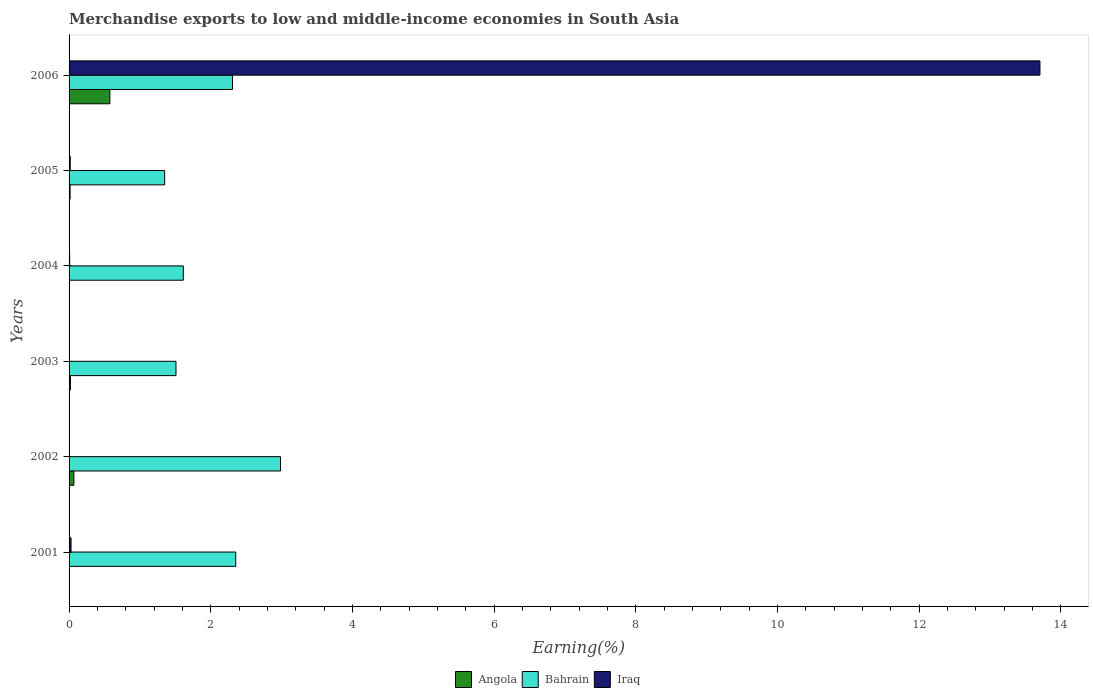How many different coloured bars are there?
Ensure brevity in your answer.  3. How many groups of bars are there?
Ensure brevity in your answer.  6. Are the number of bars per tick equal to the number of legend labels?
Offer a terse response. Yes. How many bars are there on the 4th tick from the bottom?
Ensure brevity in your answer.  3. What is the percentage of amount earned from merchandise exports in Bahrain in 2003?
Give a very brief answer. 1.51. Across all years, what is the maximum percentage of amount earned from merchandise exports in Angola?
Keep it short and to the point. 0.58. Across all years, what is the minimum percentage of amount earned from merchandise exports in Iraq?
Offer a terse response. 0. In which year was the percentage of amount earned from merchandise exports in Bahrain minimum?
Your answer should be very brief. 2005. What is the total percentage of amount earned from merchandise exports in Iraq in the graph?
Provide a short and direct response. 13.76. What is the difference between the percentage of amount earned from merchandise exports in Bahrain in 2005 and that in 2006?
Provide a succinct answer. -0.96. What is the difference between the percentage of amount earned from merchandise exports in Iraq in 2006 and the percentage of amount earned from merchandise exports in Angola in 2001?
Your response must be concise. 13.71. What is the average percentage of amount earned from merchandise exports in Bahrain per year?
Offer a terse response. 2.02. In the year 2001, what is the difference between the percentage of amount earned from merchandise exports in Iraq and percentage of amount earned from merchandise exports in Bahrain?
Keep it short and to the point. -2.33. What is the ratio of the percentage of amount earned from merchandise exports in Angola in 2004 to that in 2006?
Offer a very short reply. 0.01. Is the percentage of amount earned from merchandise exports in Iraq in 2001 less than that in 2003?
Your response must be concise. No. Is the difference between the percentage of amount earned from merchandise exports in Iraq in 2002 and 2004 greater than the difference between the percentage of amount earned from merchandise exports in Bahrain in 2002 and 2004?
Your answer should be compact. No. What is the difference between the highest and the second highest percentage of amount earned from merchandise exports in Bahrain?
Give a very brief answer. 0.63. What is the difference between the highest and the lowest percentage of amount earned from merchandise exports in Iraq?
Provide a succinct answer. 13.71. In how many years, is the percentage of amount earned from merchandise exports in Bahrain greater than the average percentage of amount earned from merchandise exports in Bahrain taken over all years?
Keep it short and to the point. 3. What does the 1st bar from the top in 2005 represents?
Ensure brevity in your answer.  Iraq. What does the 3rd bar from the bottom in 2003 represents?
Your answer should be compact. Iraq. Is it the case that in every year, the sum of the percentage of amount earned from merchandise exports in Angola and percentage of amount earned from merchandise exports in Iraq is greater than the percentage of amount earned from merchandise exports in Bahrain?
Your answer should be very brief. No. What is the difference between two consecutive major ticks on the X-axis?
Provide a succinct answer. 2. Does the graph contain grids?
Provide a succinct answer. No. What is the title of the graph?
Provide a succinct answer. Merchandise exports to low and middle-income economies in South Asia. Does "Poland" appear as one of the legend labels in the graph?
Your answer should be very brief. No. What is the label or title of the X-axis?
Provide a succinct answer. Earning(%). What is the label or title of the Y-axis?
Give a very brief answer. Years. What is the Earning(%) of Angola in 2001?
Offer a very short reply. 0. What is the Earning(%) in Bahrain in 2001?
Your answer should be compact. 2.35. What is the Earning(%) in Iraq in 2001?
Ensure brevity in your answer.  0.03. What is the Earning(%) in Angola in 2002?
Your response must be concise. 0.07. What is the Earning(%) in Bahrain in 2002?
Provide a succinct answer. 2.99. What is the Earning(%) in Iraq in 2002?
Your answer should be compact. 0. What is the Earning(%) in Angola in 2003?
Your response must be concise. 0.02. What is the Earning(%) in Bahrain in 2003?
Offer a very short reply. 1.51. What is the Earning(%) of Iraq in 2003?
Offer a terse response. 0. What is the Earning(%) in Angola in 2004?
Your answer should be very brief. 0. What is the Earning(%) of Bahrain in 2004?
Give a very brief answer. 1.61. What is the Earning(%) of Iraq in 2004?
Provide a succinct answer. 0.01. What is the Earning(%) of Angola in 2005?
Keep it short and to the point. 0.01. What is the Earning(%) of Bahrain in 2005?
Your response must be concise. 1.35. What is the Earning(%) in Iraq in 2005?
Your answer should be compact. 0.02. What is the Earning(%) in Angola in 2006?
Make the answer very short. 0.58. What is the Earning(%) in Bahrain in 2006?
Keep it short and to the point. 2.31. What is the Earning(%) in Iraq in 2006?
Provide a succinct answer. 13.71. Across all years, what is the maximum Earning(%) of Angola?
Your answer should be compact. 0.58. Across all years, what is the maximum Earning(%) in Bahrain?
Your answer should be compact. 2.99. Across all years, what is the maximum Earning(%) of Iraq?
Your answer should be very brief. 13.71. Across all years, what is the minimum Earning(%) in Angola?
Make the answer very short. 0. Across all years, what is the minimum Earning(%) in Bahrain?
Make the answer very short. 1.35. Across all years, what is the minimum Earning(%) in Iraq?
Make the answer very short. 0. What is the total Earning(%) in Angola in the graph?
Give a very brief answer. 0.68. What is the total Earning(%) of Bahrain in the graph?
Give a very brief answer. 12.12. What is the total Earning(%) of Iraq in the graph?
Your answer should be compact. 13.76. What is the difference between the Earning(%) in Angola in 2001 and that in 2002?
Give a very brief answer. -0.07. What is the difference between the Earning(%) of Bahrain in 2001 and that in 2002?
Give a very brief answer. -0.63. What is the difference between the Earning(%) in Iraq in 2001 and that in 2002?
Give a very brief answer. 0.03. What is the difference between the Earning(%) of Angola in 2001 and that in 2003?
Make the answer very short. -0.02. What is the difference between the Earning(%) in Bahrain in 2001 and that in 2003?
Make the answer very short. 0.84. What is the difference between the Earning(%) of Iraq in 2001 and that in 2003?
Keep it short and to the point. 0.03. What is the difference between the Earning(%) of Angola in 2001 and that in 2004?
Provide a short and direct response. -0. What is the difference between the Earning(%) in Bahrain in 2001 and that in 2004?
Offer a terse response. 0.74. What is the difference between the Earning(%) of Iraq in 2001 and that in 2004?
Ensure brevity in your answer.  0.02. What is the difference between the Earning(%) in Angola in 2001 and that in 2005?
Your response must be concise. -0.01. What is the difference between the Earning(%) of Bahrain in 2001 and that in 2005?
Offer a terse response. 1. What is the difference between the Earning(%) of Iraq in 2001 and that in 2005?
Ensure brevity in your answer.  0.01. What is the difference between the Earning(%) of Angola in 2001 and that in 2006?
Make the answer very short. -0.58. What is the difference between the Earning(%) of Bahrain in 2001 and that in 2006?
Offer a terse response. 0.05. What is the difference between the Earning(%) of Iraq in 2001 and that in 2006?
Offer a very short reply. -13.68. What is the difference between the Earning(%) of Angola in 2002 and that in 2003?
Ensure brevity in your answer.  0.05. What is the difference between the Earning(%) of Bahrain in 2002 and that in 2003?
Give a very brief answer. 1.48. What is the difference between the Earning(%) in Angola in 2002 and that in 2004?
Your answer should be very brief. 0.06. What is the difference between the Earning(%) in Bahrain in 2002 and that in 2004?
Keep it short and to the point. 1.37. What is the difference between the Earning(%) of Iraq in 2002 and that in 2004?
Keep it short and to the point. -0.01. What is the difference between the Earning(%) of Angola in 2002 and that in 2005?
Your answer should be very brief. 0.05. What is the difference between the Earning(%) in Bahrain in 2002 and that in 2005?
Your response must be concise. 1.64. What is the difference between the Earning(%) of Iraq in 2002 and that in 2005?
Make the answer very short. -0.01. What is the difference between the Earning(%) of Angola in 2002 and that in 2006?
Provide a succinct answer. -0.51. What is the difference between the Earning(%) in Bahrain in 2002 and that in 2006?
Your answer should be very brief. 0.68. What is the difference between the Earning(%) of Iraq in 2002 and that in 2006?
Ensure brevity in your answer.  -13.71. What is the difference between the Earning(%) of Angola in 2003 and that in 2004?
Offer a terse response. 0.01. What is the difference between the Earning(%) of Bahrain in 2003 and that in 2004?
Your response must be concise. -0.1. What is the difference between the Earning(%) in Iraq in 2003 and that in 2004?
Offer a terse response. -0.01. What is the difference between the Earning(%) in Angola in 2003 and that in 2005?
Offer a very short reply. 0. What is the difference between the Earning(%) of Bahrain in 2003 and that in 2005?
Give a very brief answer. 0.16. What is the difference between the Earning(%) in Iraq in 2003 and that in 2005?
Provide a succinct answer. -0.01. What is the difference between the Earning(%) in Angola in 2003 and that in 2006?
Ensure brevity in your answer.  -0.56. What is the difference between the Earning(%) in Bahrain in 2003 and that in 2006?
Provide a short and direct response. -0.8. What is the difference between the Earning(%) of Iraq in 2003 and that in 2006?
Ensure brevity in your answer.  -13.71. What is the difference between the Earning(%) of Angola in 2004 and that in 2005?
Your response must be concise. -0.01. What is the difference between the Earning(%) in Bahrain in 2004 and that in 2005?
Offer a terse response. 0.26. What is the difference between the Earning(%) in Iraq in 2004 and that in 2005?
Ensure brevity in your answer.  -0.01. What is the difference between the Earning(%) in Angola in 2004 and that in 2006?
Provide a short and direct response. -0.57. What is the difference between the Earning(%) of Bahrain in 2004 and that in 2006?
Keep it short and to the point. -0.69. What is the difference between the Earning(%) in Iraq in 2004 and that in 2006?
Offer a terse response. -13.7. What is the difference between the Earning(%) of Angola in 2005 and that in 2006?
Make the answer very short. -0.56. What is the difference between the Earning(%) in Bahrain in 2005 and that in 2006?
Give a very brief answer. -0.96. What is the difference between the Earning(%) in Iraq in 2005 and that in 2006?
Provide a short and direct response. -13.69. What is the difference between the Earning(%) in Angola in 2001 and the Earning(%) in Bahrain in 2002?
Your response must be concise. -2.99. What is the difference between the Earning(%) of Angola in 2001 and the Earning(%) of Iraq in 2002?
Your response must be concise. -0. What is the difference between the Earning(%) in Bahrain in 2001 and the Earning(%) in Iraq in 2002?
Your response must be concise. 2.35. What is the difference between the Earning(%) of Angola in 2001 and the Earning(%) of Bahrain in 2003?
Give a very brief answer. -1.51. What is the difference between the Earning(%) in Angola in 2001 and the Earning(%) in Iraq in 2003?
Your response must be concise. -0. What is the difference between the Earning(%) of Bahrain in 2001 and the Earning(%) of Iraq in 2003?
Ensure brevity in your answer.  2.35. What is the difference between the Earning(%) in Angola in 2001 and the Earning(%) in Bahrain in 2004?
Your answer should be very brief. -1.61. What is the difference between the Earning(%) in Angola in 2001 and the Earning(%) in Iraq in 2004?
Your answer should be compact. -0.01. What is the difference between the Earning(%) of Bahrain in 2001 and the Earning(%) of Iraq in 2004?
Keep it short and to the point. 2.35. What is the difference between the Earning(%) of Angola in 2001 and the Earning(%) of Bahrain in 2005?
Your answer should be very brief. -1.35. What is the difference between the Earning(%) in Angola in 2001 and the Earning(%) in Iraq in 2005?
Offer a terse response. -0.02. What is the difference between the Earning(%) of Bahrain in 2001 and the Earning(%) of Iraq in 2005?
Keep it short and to the point. 2.34. What is the difference between the Earning(%) in Angola in 2001 and the Earning(%) in Bahrain in 2006?
Your response must be concise. -2.31. What is the difference between the Earning(%) in Angola in 2001 and the Earning(%) in Iraq in 2006?
Give a very brief answer. -13.71. What is the difference between the Earning(%) in Bahrain in 2001 and the Earning(%) in Iraq in 2006?
Your response must be concise. -11.35. What is the difference between the Earning(%) in Angola in 2002 and the Earning(%) in Bahrain in 2003?
Your response must be concise. -1.44. What is the difference between the Earning(%) in Angola in 2002 and the Earning(%) in Iraq in 2003?
Your answer should be very brief. 0.07. What is the difference between the Earning(%) in Bahrain in 2002 and the Earning(%) in Iraq in 2003?
Provide a succinct answer. 2.98. What is the difference between the Earning(%) of Angola in 2002 and the Earning(%) of Bahrain in 2004?
Your response must be concise. -1.55. What is the difference between the Earning(%) of Angola in 2002 and the Earning(%) of Iraq in 2004?
Offer a very short reply. 0.06. What is the difference between the Earning(%) of Bahrain in 2002 and the Earning(%) of Iraq in 2004?
Your response must be concise. 2.98. What is the difference between the Earning(%) of Angola in 2002 and the Earning(%) of Bahrain in 2005?
Ensure brevity in your answer.  -1.28. What is the difference between the Earning(%) of Angola in 2002 and the Earning(%) of Iraq in 2005?
Make the answer very short. 0.05. What is the difference between the Earning(%) in Bahrain in 2002 and the Earning(%) in Iraq in 2005?
Offer a terse response. 2.97. What is the difference between the Earning(%) of Angola in 2002 and the Earning(%) of Bahrain in 2006?
Provide a succinct answer. -2.24. What is the difference between the Earning(%) of Angola in 2002 and the Earning(%) of Iraq in 2006?
Ensure brevity in your answer.  -13.64. What is the difference between the Earning(%) in Bahrain in 2002 and the Earning(%) in Iraq in 2006?
Your answer should be compact. -10.72. What is the difference between the Earning(%) in Angola in 2003 and the Earning(%) in Bahrain in 2004?
Provide a succinct answer. -1.59. What is the difference between the Earning(%) of Angola in 2003 and the Earning(%) of Iraq in 2004?
Ensure brevity in your answer.  0.01. What is the difference between the Earning(%) in Bahrain in 2003 and the Earning(%) in Iraq in 2004?
Keep it short and to the point. 1.5. What is the difference between the Earning(%) of Angola in 2003 and the Earning(%) of Bahrain in 2005?
Your answer should be very brief. -1.33. What is the difference between the Earning(%) of Angola in 2003 and the Earning(%) of Iraq in 2005?
Your response must be concise. 0. What is the difference between the Earning(%) of Bahrain in 2003 and the Earning(%) of Iraq in 2005?
Your answer should be compact. 1.49. What is the difference between the Earning(%) in Angola in 2003 and the Earning(%) in Bahrain in 2006?
Provide a succinct answer. -2.29. What is the difference between the Earning(%) of Angola in 2003 and the Earning(%) of Iraq in 2006?
Keep it short and to the point. -13.69. What is the difference between the Earning(%) in Bahrain in 2003 and the Earning(%) in Iraq in 2006?
Give a very brief answer. -12.2. What is the difference between the Earning(%) of Angola in 2004 and the Earning(%) of Bahrain in 2005?
Give a very brief answer. -1.35. What is the difference between the Earning(%) of Angola in 2004 and the Earning(%) of Iraq in 2005?
Provide a short and direct response. -0.01. What is the difference between the Earning(%) of Bahrain in 2004 and the Earning(%) of Iraq in 2005?
Offer a terse response. 1.6. What is the difference between the Earning(%) in Angola in 2004 and the Earning(%) in Bahrain in 2006?
Provide a short and direct response. -2.3. What is the difference between the Earning(%) of Angola in 2004 and the Earning(%) of Iraq in 2006?
Give a very brief answer. -13.7. What is the difference between the Earning(%) in Bahrain in 2004 and the Earning(%) in Iraq in 2006?
Provide a succinct answer. -12.09. What is the difference between the Earning(%) in Angola in 2005 and the Earning(%) in Bahrain in 2006?
Offer a very short reply. -2.29. What is the difference between the Earning(%) in Angola in 2005 and the Earning(%) in Iraq in 2006?
Provide a short and direct response. -13.69. What is the difference between the Earning(%) of Bahrain in 2005 and the Earning(%) of Iraq in 2006?
Offer a terse response. -12.36. What is the average Earning(%) in Angola per year?
Keep it short and to the point. 0.11. What is the average Earning(%) in Bahrain per year?
Provide a succinct answer. 2.02. What is the average Earning(%) of Iraq per year?
Your answer should be compact. 2.29. In the year 2001, what is the difference between the Earning(%) in Angola and Earning(%) in Bahrain?
Your answer should be compact. -2.35. In the year 2001, what is the difference between the Earning(%) in Angola and Earning(%) in Iraq?
Keep it short and to the point. -0.03. In the year 2001, what is the difference between the Earning(%) of Bahrain and Earning(%) of Iraq?
Your answer should be compact. 2.33. In the year 2002, what is the difference between the Earning(%) in Angola and Earning(%) in Bahrain?
Make the answer very short. -2.92. In the year 2002, what is the difference between the Earning(%) of Angola and Earning(%) of Iraq?
Provide a short and direct response. 0.07. In the year 2002, what is the difference between the Earning(%) in Bahrain and Earning(%) in Iraq?
Your answer should be very brief. 2.98. In the year 2003, what is the difference between the Earning(%) of Angola and Earning(%) of Bahrain?
Your answer should be very brief. -1.49. In the year 2003, what is the difference between the Earning(%) of Angola and Earning(%) of Iraq?
Make the answer very short. 0.02. In the year 2003, what is the difference between the Earning(%) in Bahrain and Earning(%) in Iraq?
Provide a succinct answer. 1.51. In the year 2004, what is the difference between the Earning(%) in Angola and Earning(%) in Bahrain?
Offer a terse response. -1.61. In the year 2004, what is the difference between the Earning(%) of Angola and Earning(%) of Iraq?
Provide a short and direct response. -0. In the year 2004, what is the difference between the Earning(%) in Bahrain and Earning(%) in Iraq?
Ensure brevity in your answer.  1.6. In the year 2005, what is the difference between the Earning(%) in Angola and Earning(%) in Bahrain?
Your answer should be compact. -1.34. In the year 2005, what is the difference between the Earning(%) in Angola and Earning(%) in Iraq?
Your answer should be very brief. -0. In the year 2005, what is the difference between the Earning(%) in Bahrain and Earning(%) in Iraq?
Provide a short and direct response. 1.33. In the year 2006, what is the difference between the Earning(%) in Angola and Earning(%) in Bahrain?
Give a very brief answer. -1.73. In the year 2006, what is the difference between the Earning(%) in Angola and Earning(%) in Iraq?
Keep it short and to the point. -13.13. In the year 2006, what is the difference between the Earning(%) of Bahrain and Earning(%) of Iraq?
Make the answer very short. -11.4. What is the ratio of the Earning(%) in Angola in 2001 to that in 2002?
Your answer should be very brief. 0. What is the ratio of the Earning(%) in Bahrain in 2001 to that in 2002?
Your response must be concise. 0.79. What is the ratio of the Earning(%) of Iraq in 2001 to that in 2002?
Offer a terse response. 14.14. What is the ratio of the Earning(%) of Angola in 2001 to that in 2003?
Offer a very short reply. 0.01. What is the ratio of the Earning(%) of Bahrain in 2001 to that in 2003?
Give a very brief answer. 1.56. What is the ratio of the Earning(%) of Iraq in 2001 to that in 2003?
Your answer should be very brief. 17.33. What is the ratio of the Earning(%) of Angola in 2001 to that in 2004?
Your answer should be compact. 0.04. What is the ratio of the Earning(%) in Bahrain in 2001 to that in 2004?
Your answer should be very brief. 1.46. What is the ratio of the Earning(%) in Iraq in 2001 to that in 2004?
Give a very brief answer. 3.42. What is the ratio of the Earning(%) of Angola in 2001 to that in 2005?
Ensure brevity in your answer.  0.01. What is the ratio of the Earning(%) of Bahrain in 2001 to that in 2005?
Give a very brief answer. 1.74. What is the ratio of the Earning(%) in Iraq in 2001 to that in 2005?
Your answer should be very brief. 1.69. What is the ratio of the Earning(%) in Bahrain in 2001 to that in 2006?
Ensure brevity in your answer.  1.02. What is the ratio of the Earning(%) of Iraq in 2001 to that in 2006?
Give a very brief answer. 0. What is the ratio of the Earning(%) of Angola in 2002 to that in 2003?
Offer a terse response. 3.53. What is the ratio of the Earning(%) in Bahrain in 2002 to that in 2003?
Your response must be concise. 1.98. What is the ratio of the Earning(%) in Iraq in 2002 to that in 2003?
Provide a short and direct response. 1.23. What is the ratio of the Earning(%) in Angola in 2002 to that in 2004?
Make the answer very short. 15.25. What is the ratio of the Earning(%) of Bahrain in 2002 to that in 2004?
Provide a short and direct response. 1.85. What is the ratio of the Earning(%) of Iraq in 2002 to that in 2004?
Provide a succinct answer. 0.24. What is the ratio of the Earning(%) of Angola in 2002 to that in 2005?
Provide a succinct answer. 4.68. What is the ratio of the Earning(%) of Bahrain in 2002 to that in 2005?
Offer a terse response. 2.21. What is the ratio of the Earning(%) of Iraq in 2002 to that in 2005?
Keep it short and to the point. 0.12. What is the ratio of the Earning(%) in Angola in 2002 to that in 2006?
Your answer should be compact. 0.12. What is the ratio of the Earning(%) of Bahrain in 2002 to that in 2006?
Offer a very short reply. 1.29. What is the ratio of the Earning(%) in Angola in 2003 to that in 2004?
Offer a very short reply. 4.32. What is the ratio of the Earning(%) in Bahrain in 2003 to that in 2004?
Make the answer very short. 0.94. What is the ratio of the Earning(%) of Iraq in 2003 to that in 2004?
Provide a succinct answer. 0.2. What is the ratio of the Earning(%) of Angola in 2003 to that in 2005?
Keep it short and to the point. 1.32. What is the ratio of the Earning(%) of Bahrain in 2003 to that in 2005?
Provide a succinct answer. 1.12. What is the ratio of the Earning(%) of Iraq in 2003 to that in 2005?
Keep it short and to the point. 0.1. What is the ratio of the Earning(%) of Angola in 2003 to that in 2006?
Keep it short and to the point. 0.03. What is the ratio of the Earning(%) of Bahrain in 2003 to that in 2006?
Keep it short and to the point. 0.65. What is the ratio of the Earning(%) in Iraq in 2003 to that in 2006?
Make the answer very short. 0. What is the ratio of the Earning(%) of Angola in 2004 to that in 2005?
Offer a terse response. 0.31. What is the ratio of the Earning(%) of Bahrain in 2004 to that in 2005?
Your answer should be compact. 1.2. What is the ratio of the Earning(%) of Iraq in 2004 to that in 2005?
Offer a terse response. 0.49. What is the ratio of the Earning(%) of Angola in 2004 to that in 2006?
Your answer should be compact. 0.01. What is the ratio of the Earning(%) of Bahrain in 2004 to that in 2006?
Offer a very short reply. 0.7. What is the ratio of the Earning(%) of Iraq in 2004 to that in 2006?
Offer a very short reply. 0. What is the ratio of the Earning(%) in Angola in 2005 to that in 2006?
Your answer should be very brief. 0.03. What is the ratio of the Earning(%) of Bahrain in 2005 to that in 2006?
Your answer should be compact. 0.58. What is the ratio of the Earning(%) in Iraq in 2005 to that in 2006?
Your answer should be compact. 0. What is the difference between the highest and the second highest Earning(%) of Angola?
Give a very brief answer. 0.51. What is the difference between the highest and the second highest Earning(%) of Bahrain?
Keep it short and to the point. 0.63. What is the difference between the highest and the second highest Earning(%) in Iraq?
Offer a very short reply. 13.68. What is the difference between the highest and the lowest Earning(%) in Angola?
Offer a terse response. 0.58. What is the difference between the highest and the lowest Earning(%) of Bahrain?
Provide a succinct answer. 1.64. What is the difference between the highest and the lowest Earning(%) of Iraq?
Provide a short and direct response. 13.71. 